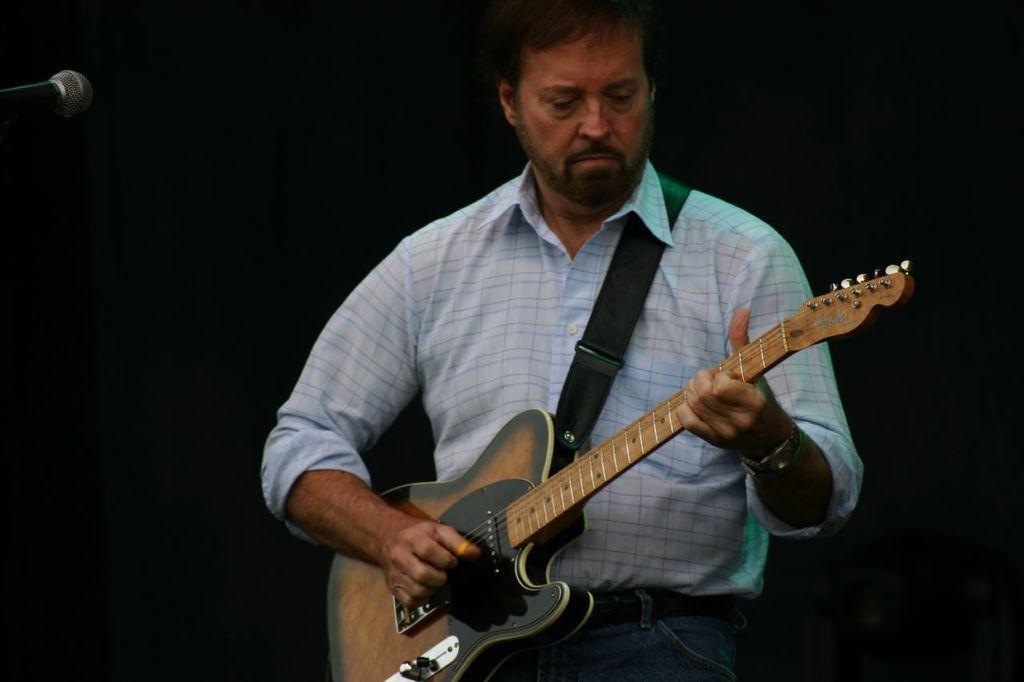Describe this image in one or two sentences. A man is playing a guitar. 